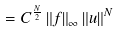<formula> <loc_0><loc_0><loc_500><loc_500>= C ^ { \frac { N } { 2 } } \left \| f \right \| _ { \infty } \left \| u \right \| ^ { N }</formula> 